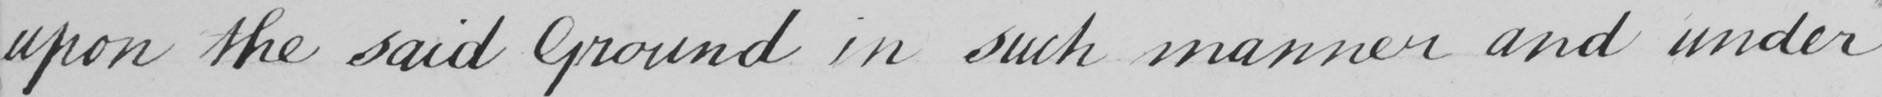Please provide the text content of this handwritten line. upon the said Ground in such manner and under 